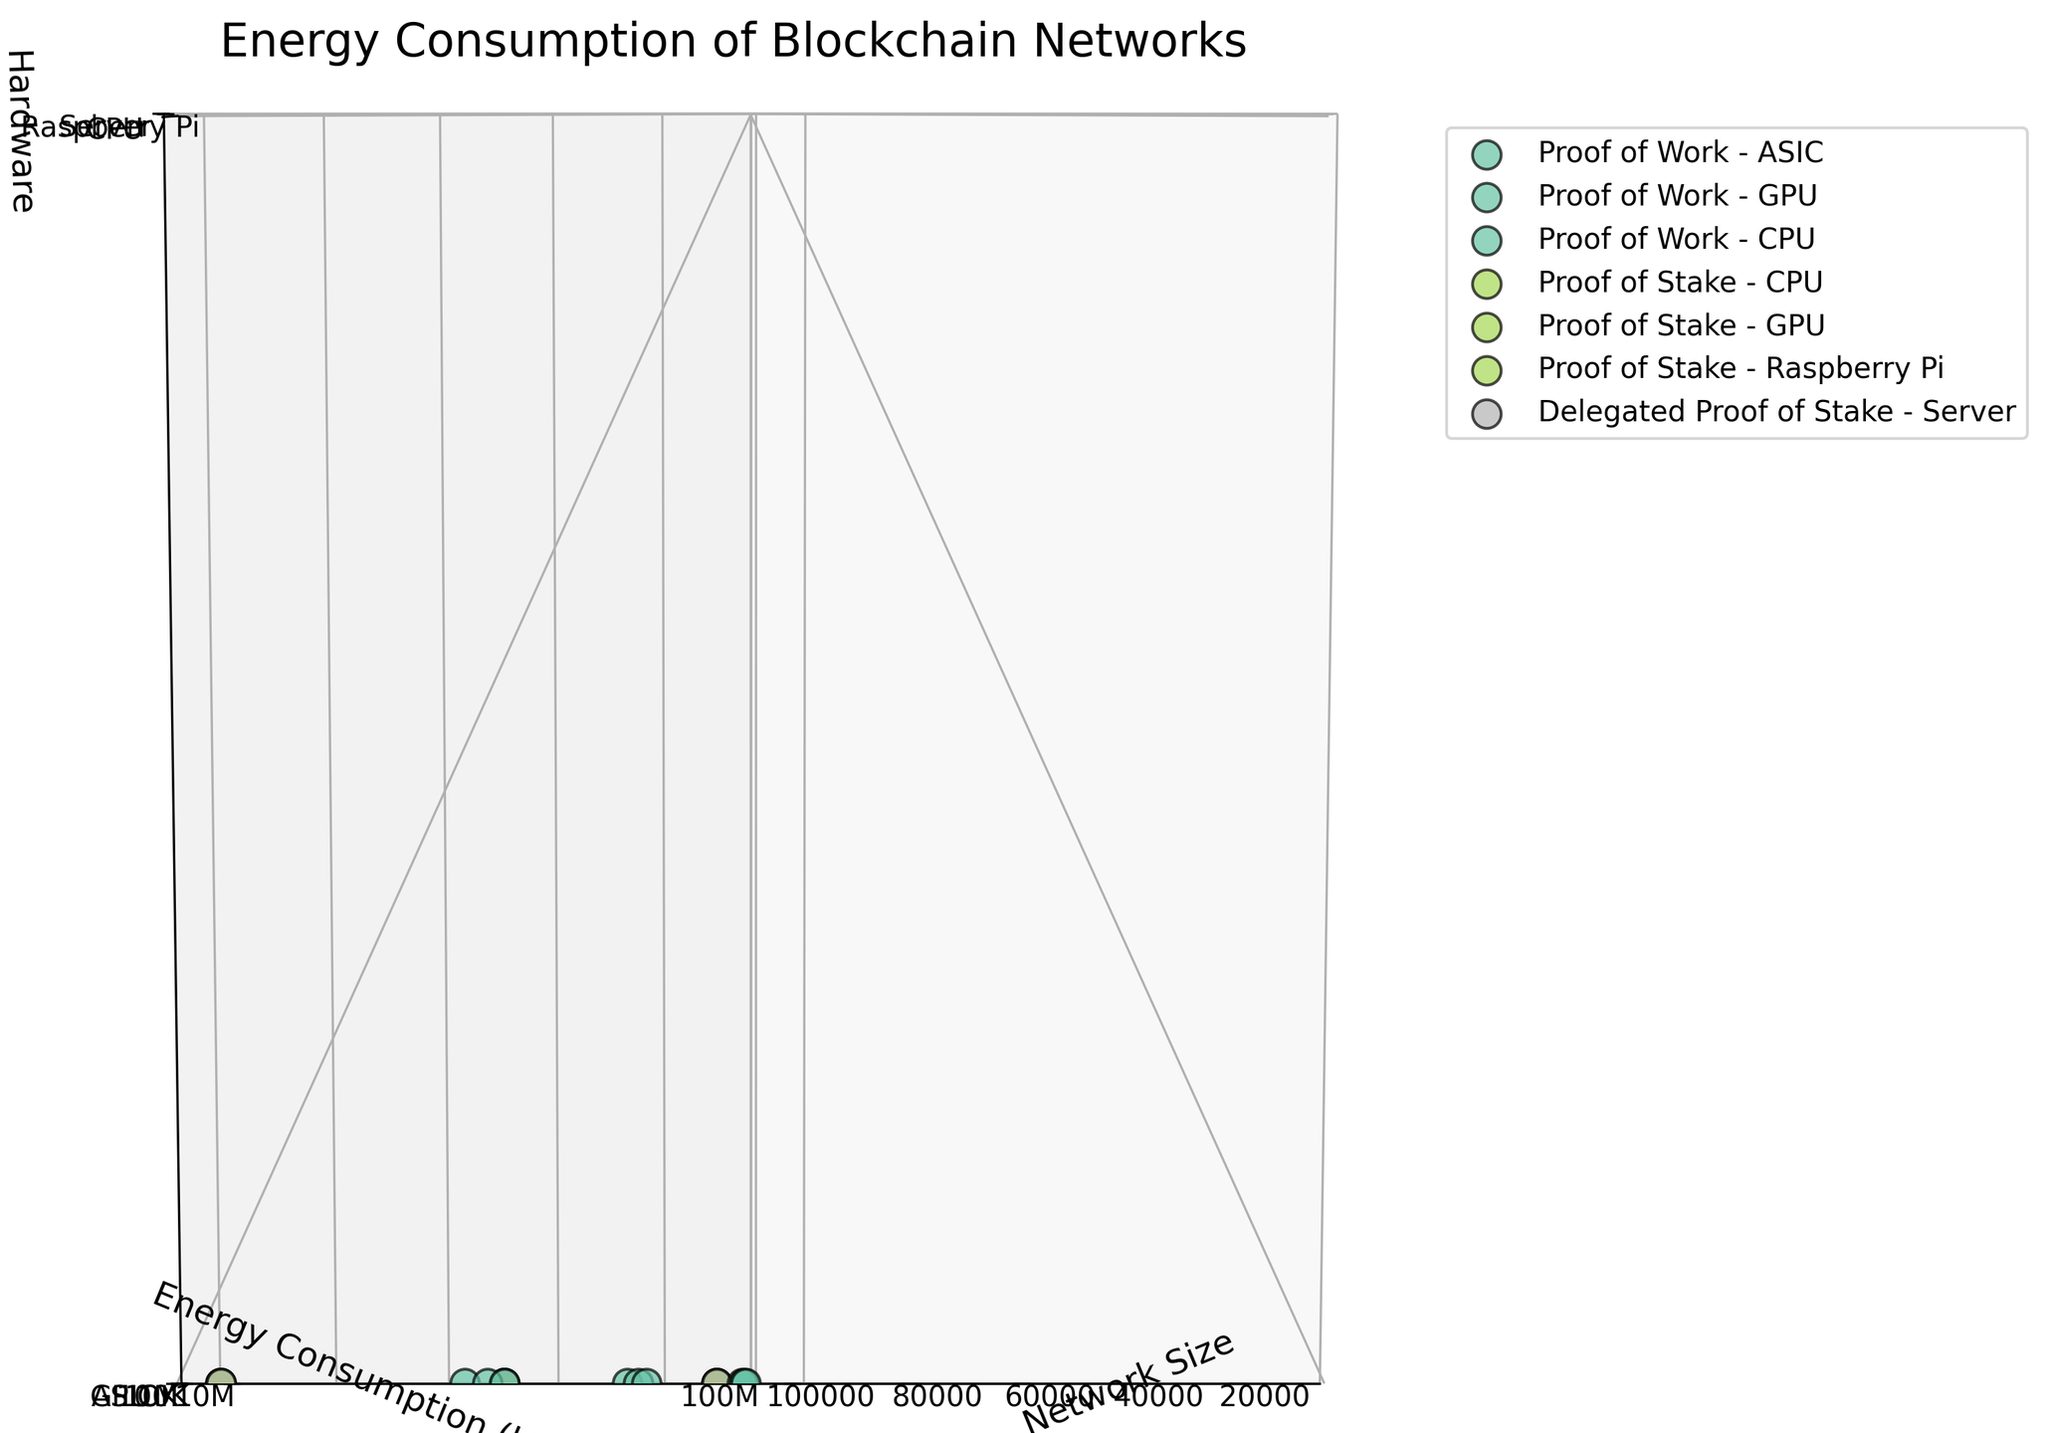What is the title of the figure? The title is displayed at the top of the figure.
Answer: Energy Consumption of Blockchain Networks Which algorithm and hardware type have the highest energy consumption for a network size of 100,000? Locate the point at Network Size axis = 100,000, and compare the energy consumption values (y-axis) for each hardware type across different algorithms.
Answer: Proof of Work, CPU What is the relationship between network size and energy consumption for Proof of Work using ASIC hardware? Follow the trajectory of the data points associated with Proof of Work-ASIC across different network sizes on the x-axis and observe their positions on the y-axis. Energy consumption increases significantly with network size.
Answer: Positive correlation, energy consumption increases with network size At a network size of 50,000, which algorithm and hardware combination consumes the least energy? Locate the data points at Network Size = 50,000, and identify the combination with the lowest y-axis value for energy consumption.
Answer: Proof of Stake, Raspberry Pi What is the main hardware type associated with Delegated Proof of Stake? Identify the hardware used for Delegated Proof of Stake by examining the labels in the legend and 3D points.
Answer: Server Does the energy consumption scale linearly with network size for Proof of Stake using CPU? Check the spacing and ratios of energy consumption values for CPU at network sizes 10,000, 50,000, and 100,000 on the y-axis.
Answer: No, it scales less than linearly Between Proof of Work using GPU and Proof of Stake using GPU, which consumes more energy for a network size of 10,000? Identify data points for Proof of Work and Proof of Stake using GPU at Network Size = 10,000 and compare their positions on the y-axis.
Answer: Proof of Work, GPU What is the order of energy consumption for Proof of Work across different hardware types at a network size of 100,000? Find the points for Proof of Work at Network Size = 100,000 and rank the energy consumption values on the y-axis.
Answer: CPU > ASIC > GPU How does energy consumption differ among various blockchain algorithms with the same hardware (CPU) at a network size of 50,000? Locate points for CPU hardware at Network Size = 50,000 and compare the y-axis values for each algorithm. Proof of Work has the highest, followed by Delegated Proof of Stake, with Proof of Stake having the lowest energy consumption.
Answer: Proof of Work > Delegated Proof of Stake > Proof of Stake 